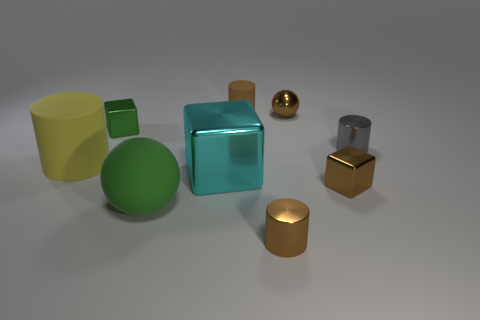Are there any other things that are the same size as the green rubber ball?
Your response must be concise. Yes. The yellow rubber thing that is the same size as the matte sphere is what shape?
Make the answer very short. Cylinder. Is there a shiny object that has the same shape as the small brown matte object?
Ensure brevity in your answer.  Yes. Are there any small gray cylinders that are to the right of the matte thing in front of the brown block that is in front of the big cyan shiny cube?
Make the answer very short. Yes. Are there more tiny metallic cylinders that are in front of the cyan cube than small metal cylinders on the left side of the gray metal thing?
Offer a very short reply. No. What material is the cube that is the same size as the green rubber thing?
Your response must be concise. Metal. What number of big things are gray metallic cylinders or blue rubber cubes?
Your response must be concise. 0. Does the tiny green shiny object have the same shape as the yellow rubber thing?
Provide a succinct answer. No. What number of matte objects are both in front of the cyan shiny block and behind the brown metallic block?
Offer a terse response. 0. Is there anything else that has the same color as the big shiny cube?
Your answer should be very brief. No. 